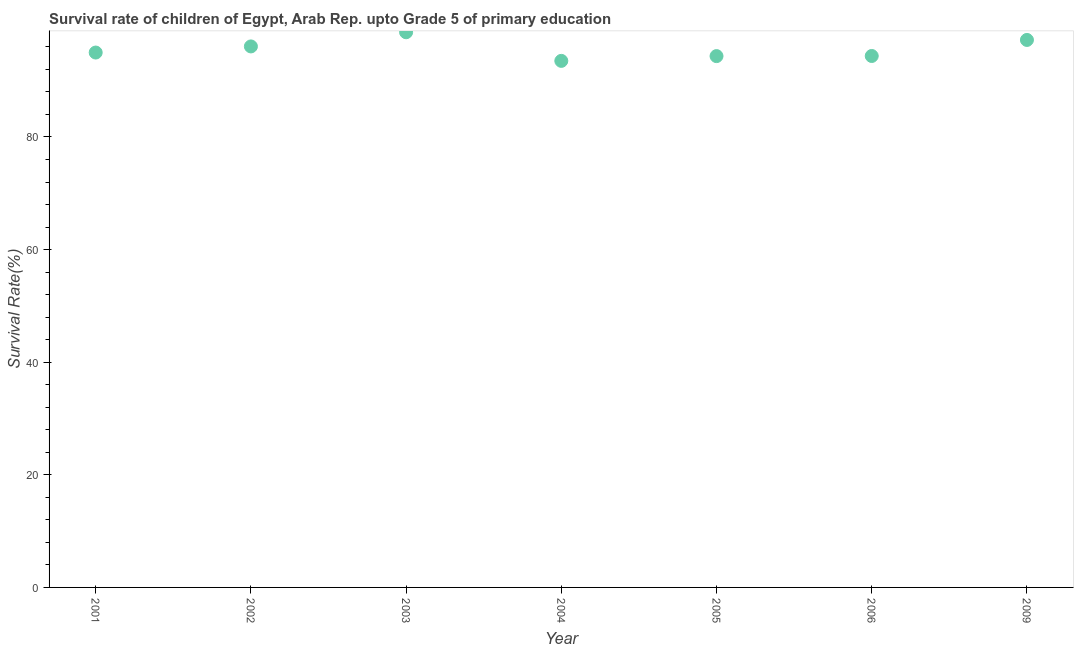What is the survival rate in 2005?
Your answer should be very brief. 94.37. Across all years, what is the maximum survival rate?
Offer a terse response. 98.6. Across all years, what is the minimum survival rate?
Provide a succinct answer. 93.52. In which year was the survival rate maximum?
Your answer should be very brief. 2003. What is the sum of the survival rate?
Keep it short and to the point. 669.2. What is the difference between the survival rate in 2002 and 2006?
Make the answer very short. 1.7. What is the average survival rate per year?
Ensure brevity in your answer.  95.6. What is the median survival rate?
Offer a very short reply. 95. What is the ratio of the survival rate in 2003 to that in 2005?
Your answer should be very brief. 1.04. What is the difference between the highest and the second highest survival rate?
Your response must be concise. 1.36. What is the difference between the highest and the lowest survival rate?
Your answer should be compact. 5.08. In how many years, is the survival rate greater than the average survival rate taken over all years?
Your answer should be compact. 3. Does the survival rate monotonically increase over the years?
Offer a very short reply. No. How many dotlines are there?
Give a very brief answer. 1. What is the title of the graph?
Give a very brief answer. Survival rate of children of Egypt, Arab Rep. upto Grade 5 of primary education. What is the label or title of the Y-axis?
Your response must be concise. Survival Rate(%). What is the Survival Rate(%) in 2001?
Give a very brief answer. 95. What is the Survival Rate(%) in 2002?
Offer a terse response. 96.09. What is the Survival Rate(%) in 2003?
Your answer should be very brief. 98.6. What is the Survival Rate(%) in 2004?
Offer a terse response. 93.52. What is the Survival Rate(%) in 2005?
Your answer should be compact. 94.37. What is the Survival Rate(%) in 2006?
Ensure brevity in your answer.  94.39. What is the Survival Rate(%) in 2009?
Make the answer very short. 97.24. What is the difference between the Survival Rate(%) in 2001 and 2002?
Offer a terse response. -1.09. What is the difference between the Survival Rate(%) in 2001 and 2003?
Give a very brief answer. -3.6. What is the difference between the Survival Rate(%) in 2001 and 2004?
Your answer should be compact. 1.48. What is the difference between the Survival Rate(%) in 2001 and 2005?
Provide a short and direct response. 0.63. What is the difference between the Survival Rate(%) in 2001 and 2006?
Provide a succinct answer. 0.61. What is the difference between the Survival Rate(%) in 2001 and 2009?
Make the answer very short. -2.24. What is the difference between the Survival Rate(%) in 2002 and 2003?
Provide a short and direct response. -2.52. What is the difference between the Survival Rate(%) in 2002 and 2004?
Offer a very short reply. 2.57. What is the difference between the Survival Rate(%) in 2002 and 2005?
Provide a short and direct response. 1.72. What is the difference between the Survival Rate(%) in 2002 and 2006?
Provide a short and direct response. 1.7. What is the difference between the Survival Rate(%) in 2002 and 2009?
Make the answer very short. -1.15. What is the difference between the Survival Rate(%) in 2003 and 2004?
Provide a short and direct response. 5.08. What is the difference between the Survival Rate(%) in 2003 and 2005?
Make the answer very short. 4.24. What is the difference between the Survival Rate(%) in 2003 and 2006?
Your response must be concise. 4.21. What is the difference between the Survival Rate(%) in 2003 and 2009?
Offer a very short reply. 1.36. What is the difference between the Survival Rate(%) in 2004 and 2005?
Ensure brevity in your answer.  -0.85. What is the difference between the Survival Rate(%) in 2004 and 2006?
Keep it short and to the point. -0.87. What is the difference between the Survival Rate(%) in 2004 and 2009?
Ensure brevity in your answer.  -3.72. What is the difference between the Survival Rate(%) in 2005 and 2006?
Give a very brief answer. -0.02. What is the difference between the Survival Rate(%) in 2005 and 2009?
Your answer should be compact. -2.87. What is the difference between the Survival Rate(%) in 2006 and 2009?
Offer a terse response. -2.85. What is the ratio of the Survival Rate(%) in 2001 to that in 2002?
Keep it short and to the point. 0.99. What is the ratio of the Survival Rate(%) in 2001 to that in 2004?
Provide a short and direct response. 1.02. What is the ratio of the Survival Rate(%) in 2002 to that in 2003?
Make the answer very short. 0.97. What is the ratio of the Survival Rate(%) in 2003 to that in 2004?
Provide a succinct answer. 1.05. What is the ratio of the Survival Rate(%) in 2003 to that in 2005?
Your response must be concise. 1.04. What is the ratio of the Survival Rate(%) in 2003 to that in 2006?
Provide a succinct answer. 1.04. What is the ratio of the Survival Rate(%) in 2003 to that in 2009?
Your answer should be very brief. 1.01. What is the ratio of the Survival Rate(%) in 2004 to that in 2005?
Ensure brevity in your answer.  0.99. What is the ratio of the Survival Rate(%) in 2004 to that in 2006?
Ensure brevity in your answer.  0.99. 